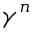Convert formula to latex. <formula><loc_0><loc_0><loc_500><loc_500>\gamma ^ { n }</formula> 